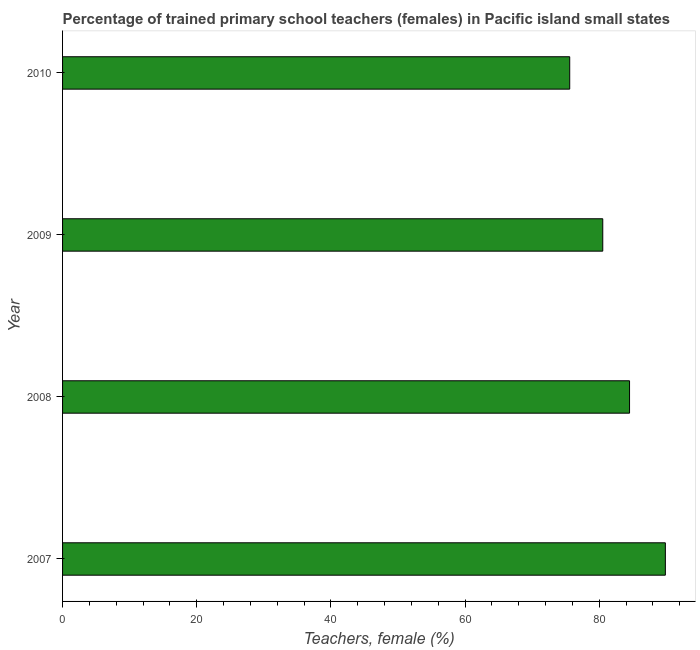Does the graph contain any zero values?
Keep it short and to the point. No. Does the graph contain grids?
Provide a short and direct response. No. What is the title of the graph?
Ensure brevity in your answer.  Percentage of trained primary school teachers (females) in Pacific island small states. What is the label or title of the X-axis?
Your answer should be compact. Teachers, female (%). What is the label or title of the Y-axis?
Offer a very short reply. Year. What is the percentage of trained female teachers in 2007?
Your answer should be compact. 89.84. Across all years, what is the maximum percentage of trained female teachers?
Provide a short and direct response. 89.84. Across all years, what is the minimum percentage of trained female teachers?
Offer a very short reply. 75.59. In which year was the percentage of trained female teachers minimum?
Offer a terse response. 2010. What is the sum of the percentage of trained female teachers?
Your answer should be very brief. 330.46. What is the difference between the percentage of trained female teachers in 2007 and 2009?
Ensure brevity in your answer.  9.33. What is the average percentage of trained female teachers per year?
Provide a succinct answer. 82.61. What is the median percentage of trained female teachers?
Your answer should be very brief. 82.51. In how many years, is the percentage of trained female teachers greater than 52 %?
Provide a short and direct response. 4. Do a majority of the years between 2009 and 2010 (inclusive) have percentage of trained female teachers greater than 60 %?
Offer a very short reply. Yes. What is the ratio of the percentage of trained female teachers in 2007 to that in 2010?
Offer a very short reply. 1.19. Is the percentage of trained female teachers in 2007 less than that in 2010?
Offer a terse response. No. Is the difference between the percentage of trained female teachers in 2007 and 2008 greater than the difference between any two years?
Give a very brief answer. No. What is the difference between the highest and the second highest percentage of trained female teachers?
Ensure brevity in your answer.  5.34. What is the difference between the highest and the lowest percentage of trained female teachers?
Your answer should be very brief. 14.25. In how many years, is the percentage of trained female teachers greater than the average percentage of trained female teachers taken over all years?
Keep it short and to the point. 2. How many bars are there?
Ensure brevity in your answer.  4. How many years are there in the graph?
Keep it short and to the point. 4. What is the difference between two consecutive major ticks on the X-axis?
Make the answer very short. 20. What is the Teachers, female (%) in 2007?
Your answer should be very brief. 89.84. What is the Teachers, female (%) in 2008?
Your answer should be very brief. 84.51. What is the Teachers, female (%) of 2009?
Provide a short and direct response. 80.52. What is the Teachers, female (%) in 2010?
Provide a succinct answer. 75.59. What is the difference between the Teachers, female (%) in 2007 and 2008?
Make the answer very short. 5.34. What is the difference between the Teachers, female (%) in 2007 and 2009?
Your answer should be compact. 9.33. What is the difference between the Teachers, female (%) in 2007 and 2010?
Make the answer very short. 14.25. What is the difference between the Teachers, female (%) in 2008 and 2009?
Your response must be concise. 3.99. What is the difference between the Teachers, female (%) in 2008 and 2010?
Offer a very short reply. 8.92. What is the difference between the Teachers, female (%) in 2009 and 2010?
Provide a short and direct response. 4.93. What is the ratio of the Teachers, female (%) in 2007 to that in 2008?
Provide a short and direct response. 1.06. What is the ratio of the Teachers, female (%) in 2007 to that in 2009?
Provide a short and direct response. 1.12. What is the ratio of the Teachers, female (%) in 2007 to that in 2010?
Give a very brief answer. 1.19. What is the ratio of the Teachers, female (%) in 2008 to that in 2010?
Offer a terse response. 1.12. What is the ratio of the Teachers, female (%) in 2009 to that in 2010?
Ensure brevity in your answer.  1.06. 